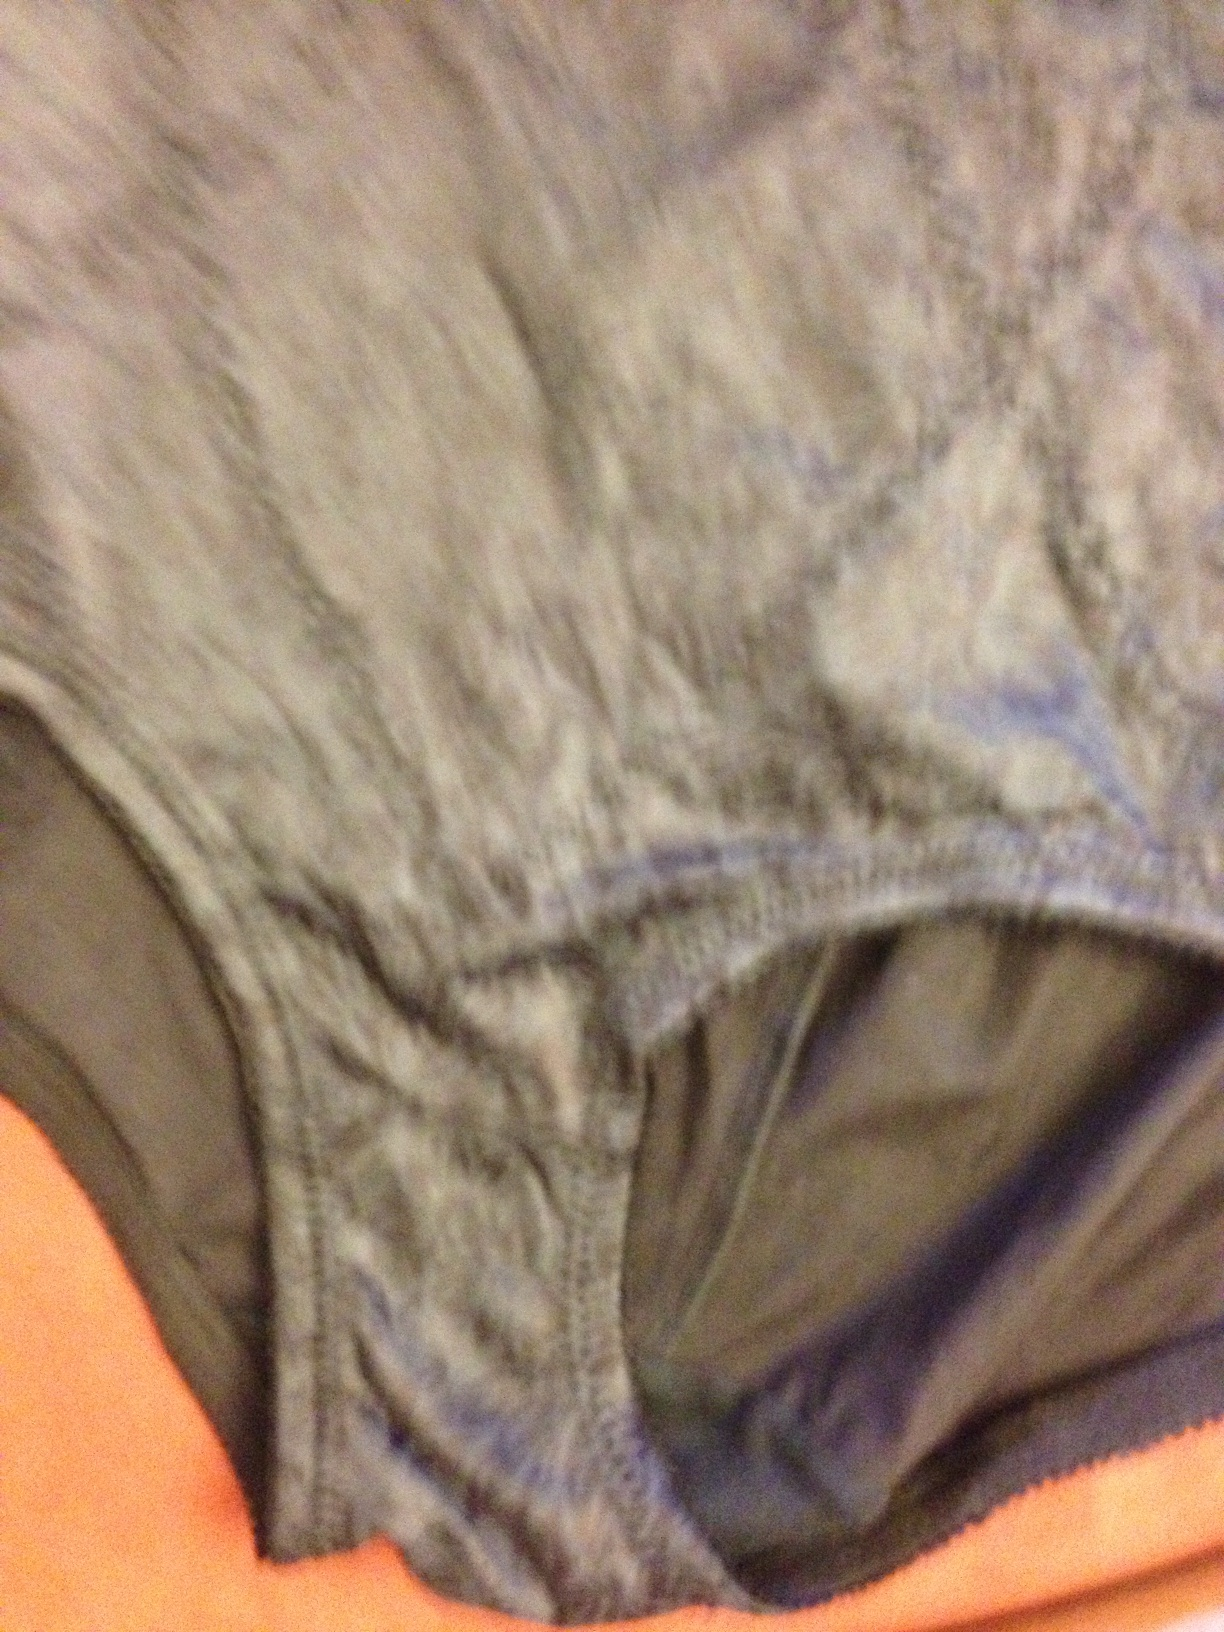What color is this? Thank you. The item in the image predominantly features a smokey grey color with slight marbling effects that suggest a worn texture, often seen in clothing fabrics like the underwear shown. 